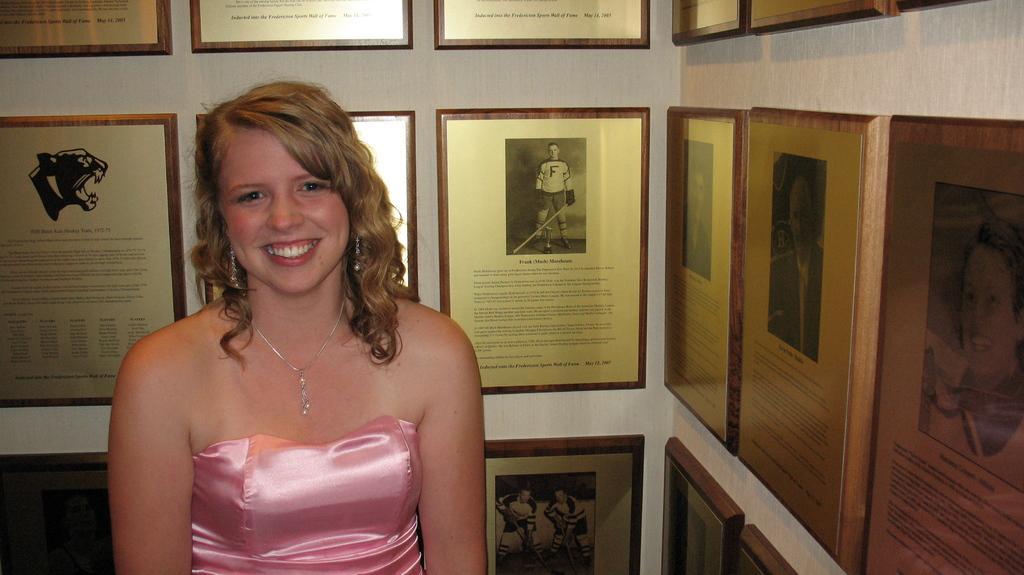Who or what is present in the image? There is a person in the image. What is the person wearing? The person is wearing a pink dress. What can be seen in the background of the image? There are frames attached to a white wall in the background of the image. What type of twig is the person holding in the image? There is no twig present in the image. Can you describe the person's tongue in the image? There is no information about the person's tongue in the image. 